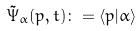<formula> <loc_0><loc_0><loc_500><loc_500>\tilde { \Psi } _ { \alpha } ( p , t ) \colon = \langle p | \alpha \rangle</formula> 